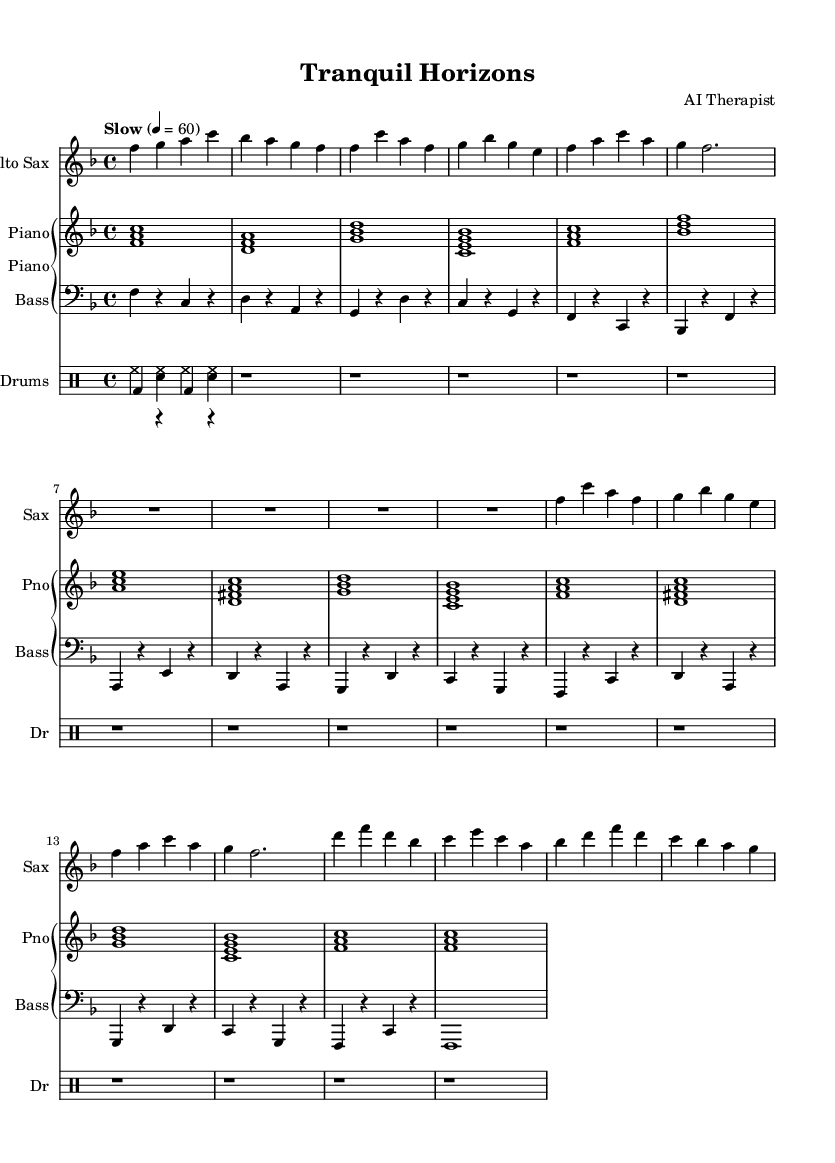What is the key signature of this music? The key signature is F major, which has one flat (B flat) indicated at the beginning of the staff.
Answer: F major What is the time signature of this music? The time signature is 4/4, which means there are four beats in each measure, and the quarter note gets one beat. This is indicated right after the clef sign on the first staff.
Answer: 4/4 What is the tempo marking for the piece? The tempo marking indicates "Slow" with a metronome mark of 60 beats per minute, which suggests a relaxed pace suited for calming music.
Answer: Slow How many measures are in the A section of the piece? The A section consists of two phrases, each with four measures, totaling eight measures. You can identify these measures based on the repeated phrases in the score.
Answer: 8 measures What type of rhythmic pattern is primarily used in the drums part? The drums part primarily features a simple brush pattern, indicated by the notations for hi-hats and snare in a syncopated rhythm alongside a bass drum.
Answer: Brush pattern What is the role of the saxophone in this composition? The saxophone in this piece plays a melodic lead, capturing the essence of a jazz ballad; it plays the main theme and interacts harmonically with the piano and bass.
Answer: Melodic lead How does the harmony in the piano part support the overall calming effect of the piece? The harmony in the piano consists of simplified chords that create a smooth, flowing background, enhancing the soothing nature of the overall music arrangement designed for relaxation.
Answer: Smooth, flowing chords 